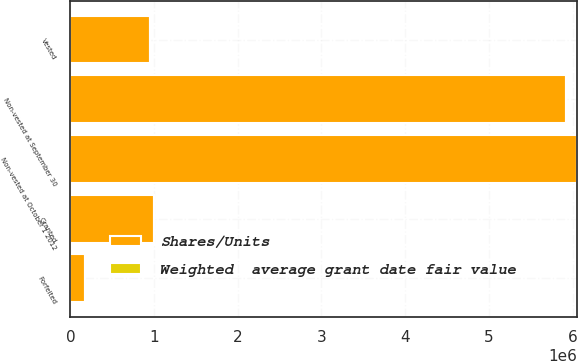Convert chart to OTSL. <chart><loc_0><loc_0><loc_500><loc_500><stacked_bar_chart><ecel><fcel>Non-vested at October 1 2012<fcel>Granted<fcel>Vested<fcel>Forfeited<fcel>Non-vested at September 30<nl><fcel>Shares/Units<fcel>6.05079e+06<fcel>1.00123e+06<fcel>954805<fcel>179804<fcel>5.91741e+06<nl><fcel>Weighted  average grant date fair value<fcel>29.87<fcel>38.12<fcel>26.86<fcel>33.16<fcel>31.66<nl></chart> 